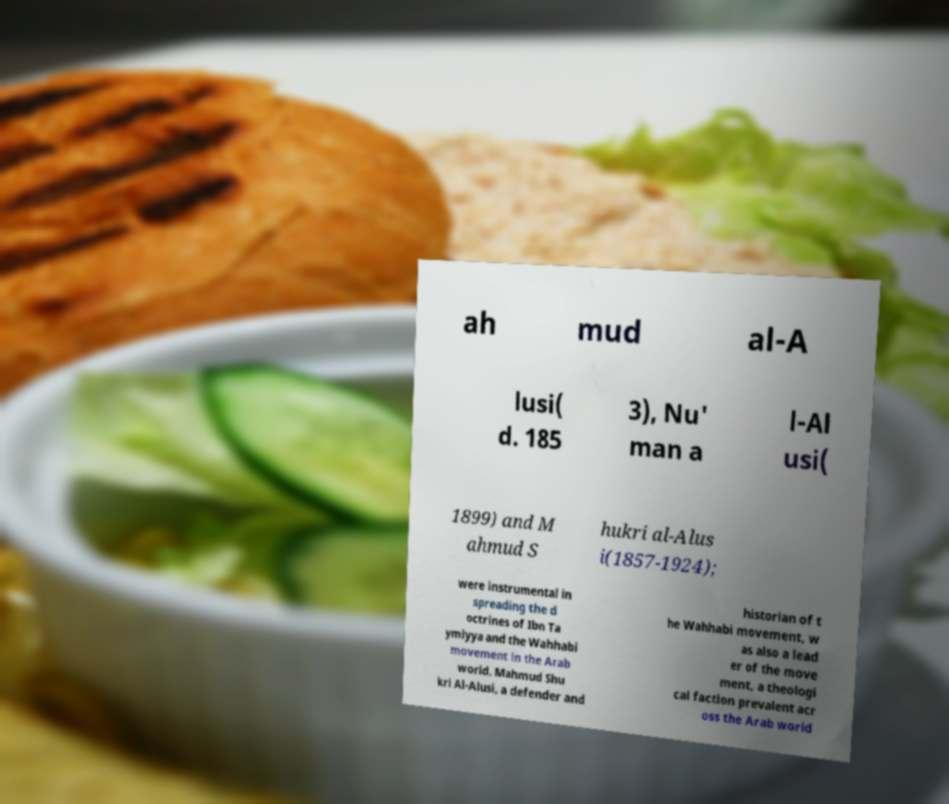I need the written content from this picture converted into text. Can you do that? ah mud al-A lusi( d. 185 3), Nu' man a l-Al usi( 1899) and M ahmud S hukri al-Alus i(1857-1924); were instrumental in spreading the d octrines of Ibn Ta ymiyya and the Wahhabi movement in the Arab world. Mahmud Shu kri Al-Alusi, a defender and historian of t he Wahhabi movement, w as also a lead er of the move ment, a theologi cal faction prevalent acr oss the Arab world 